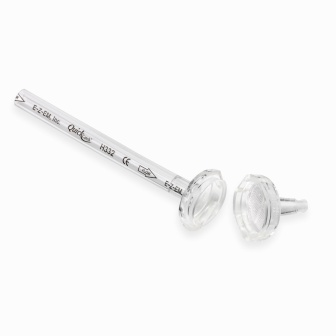What do the engravings signify? The engravings on the rod - 'Esker,' 'Pride,' and 'H42' - are intriguing and open to interpretation. 'Esker' could be the brand or designer's name, denoting quality and craftsmanship. 'Pride' might symbolize the company's values or the excellence they infuse into their products. 'H42' could be indicative of a specific model number, batch, or production code, possibly referencing a series or category within the brand's offerings. These detailed markings not only enhance the rod's aesthetic appeal but also provide unique identifiers that could be significant for collectors or users seeking authenticity and traceability. 